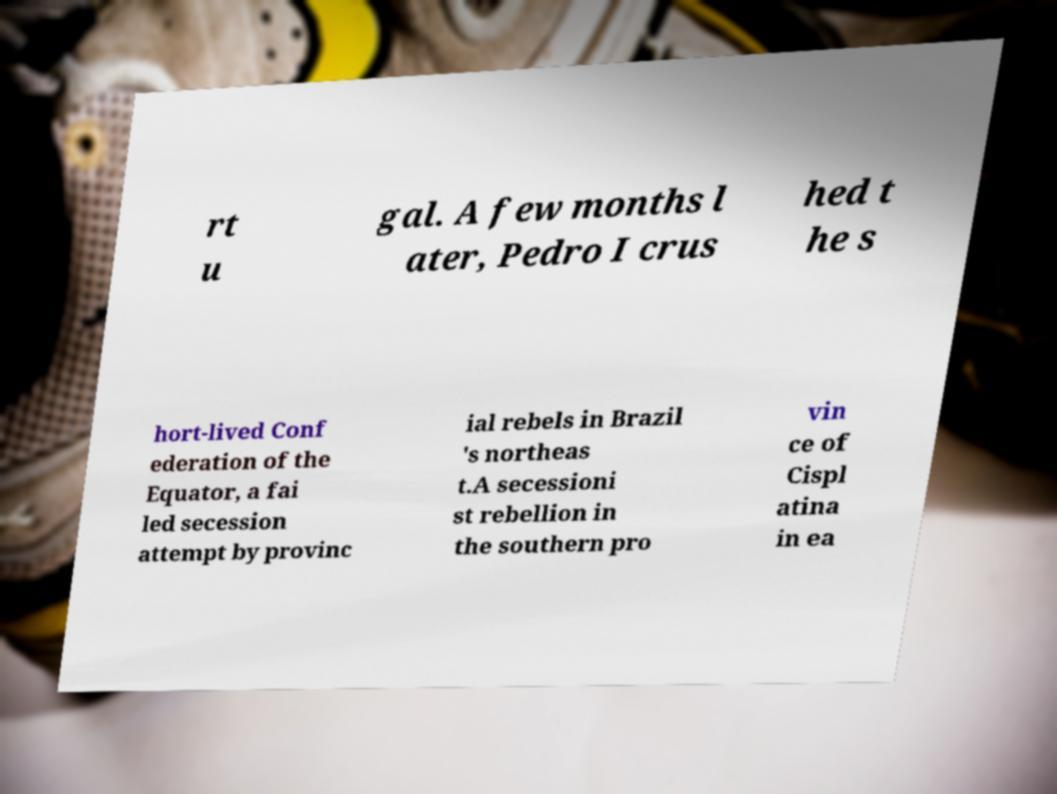Could you extract and type out the text from this image? rt u gal. A few months l ater, Pedro I crus hed t he s hort-lived Conf ederation of the Equator, a fai led secession attempt by provinc ial rebels in Brazil 's northeas t.A secessioni st rebellion in the southern pro vin ce of Cispl atina in ea 